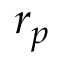<formula> <loc_0><loc_0><loc_500><loc_500>r _ { p }</formula> 